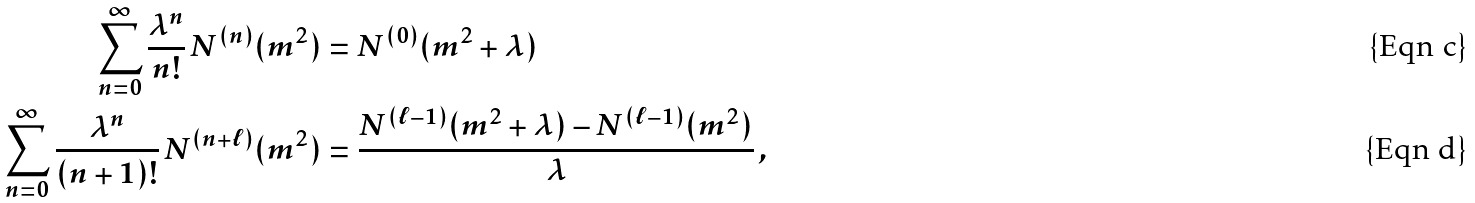Convert formula to latex. <formula><loc_0><loc_0><loc_500><loc_500>\sum _ { n = 0 } ^ { \infty } \frac { \lambda ^ { n } } { n ! } \, N ^ { ( n ) } ( m ^ { 2 } ) & = N ^ { ( 0 ) } ( m ^ { 2 } + \lambda ) \\ \sum _ { n = 0 } ^ { \infty } \frac { \lambda ^ { n } } { ( n + 1 ) ! } \, N ^ { ( n + \ell ) } ( m ^ { 2 } ) & = \frac { N ^ { ( \ell - 1 ) } ( m ^ { 2 } + \lambda ) - N ^ { ( \ell - 1 ) } ( m ^ { 2 } ) } { \lambda } \, ,</formula> 